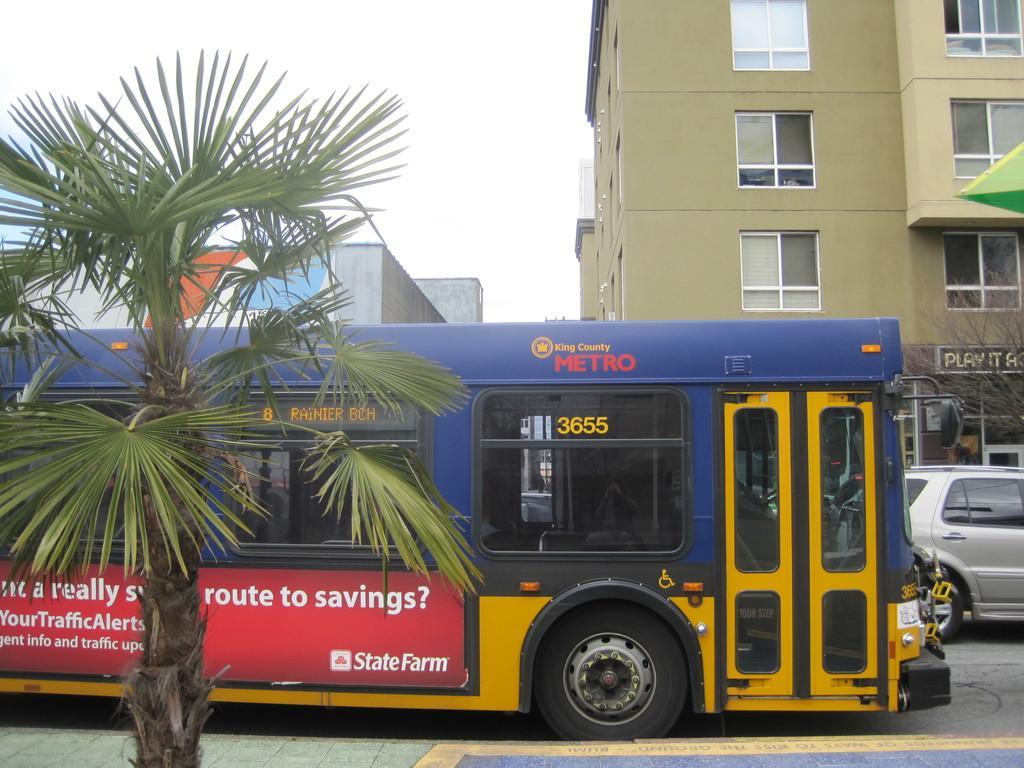Please provide a concise description of this image. In the picture we can see a path with a tree on it and besides, we can see a bus on the road and a car beside to it and in the background, we can see a building with a window and glasses and some other buildings beside it and we can also see a sky. 